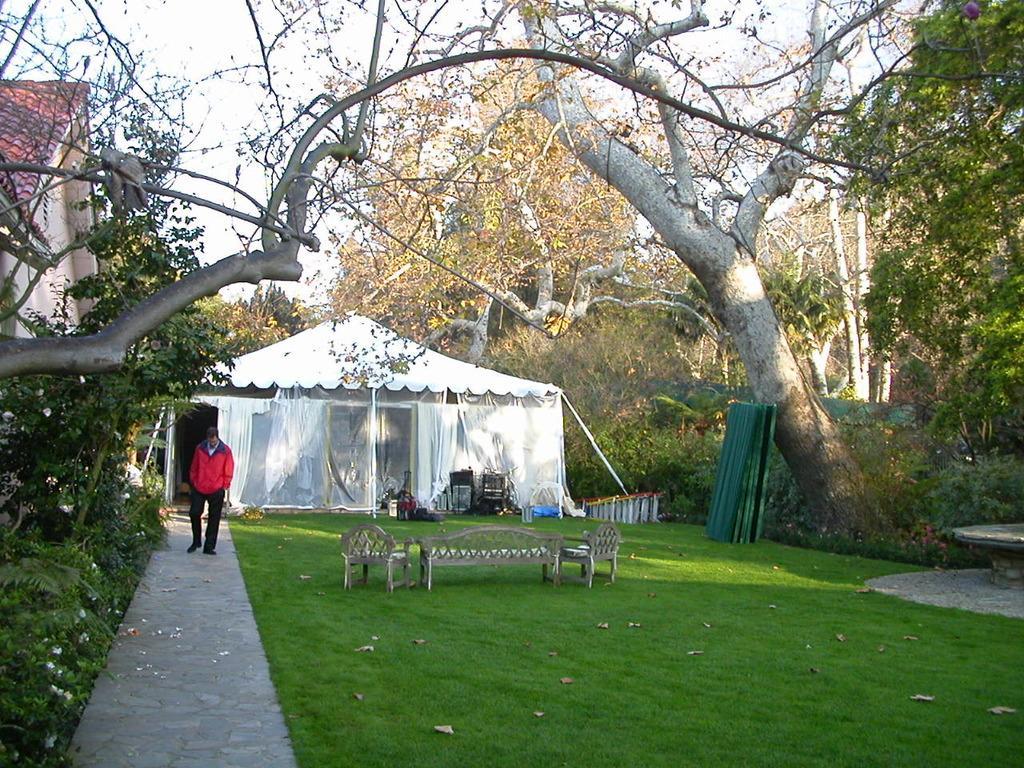Please provide a concise description of this image. This picture is clicked outside. On the right we can see the benches and the green grass and there is a trunk of a tree, plants, trees, tent, curtains and some other objects placed on the ground. On the left there is a person walking on the ground and we can see the planets, sky and the house. 